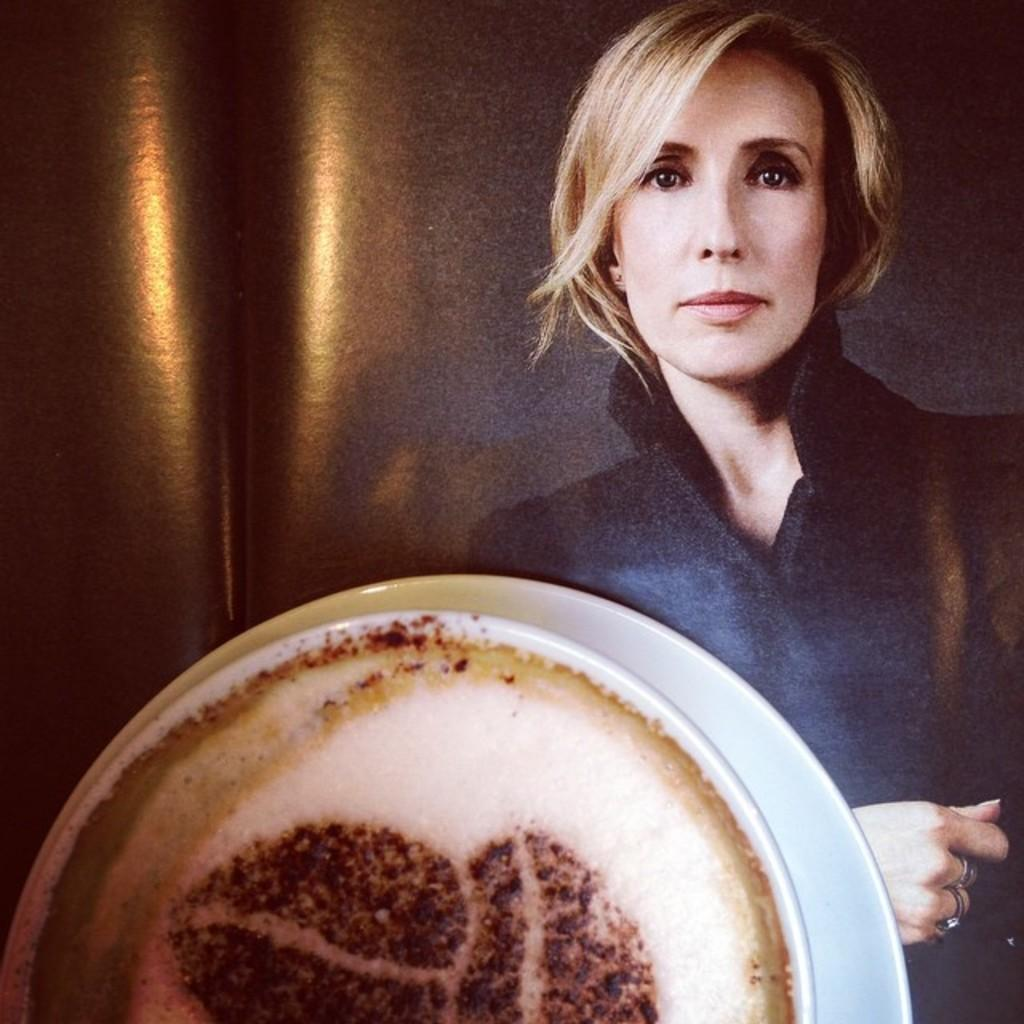What objects are present in the image related to serving a beverage? There is a cup and saucer in the image. Where is the woman located in the image? The woman is on the right side of the image. What is in the cup? There is a drink in the cup. What type of fruit is the woman holding in the image? There is no fruit visible in the image; the woman is not holding any fruit. 